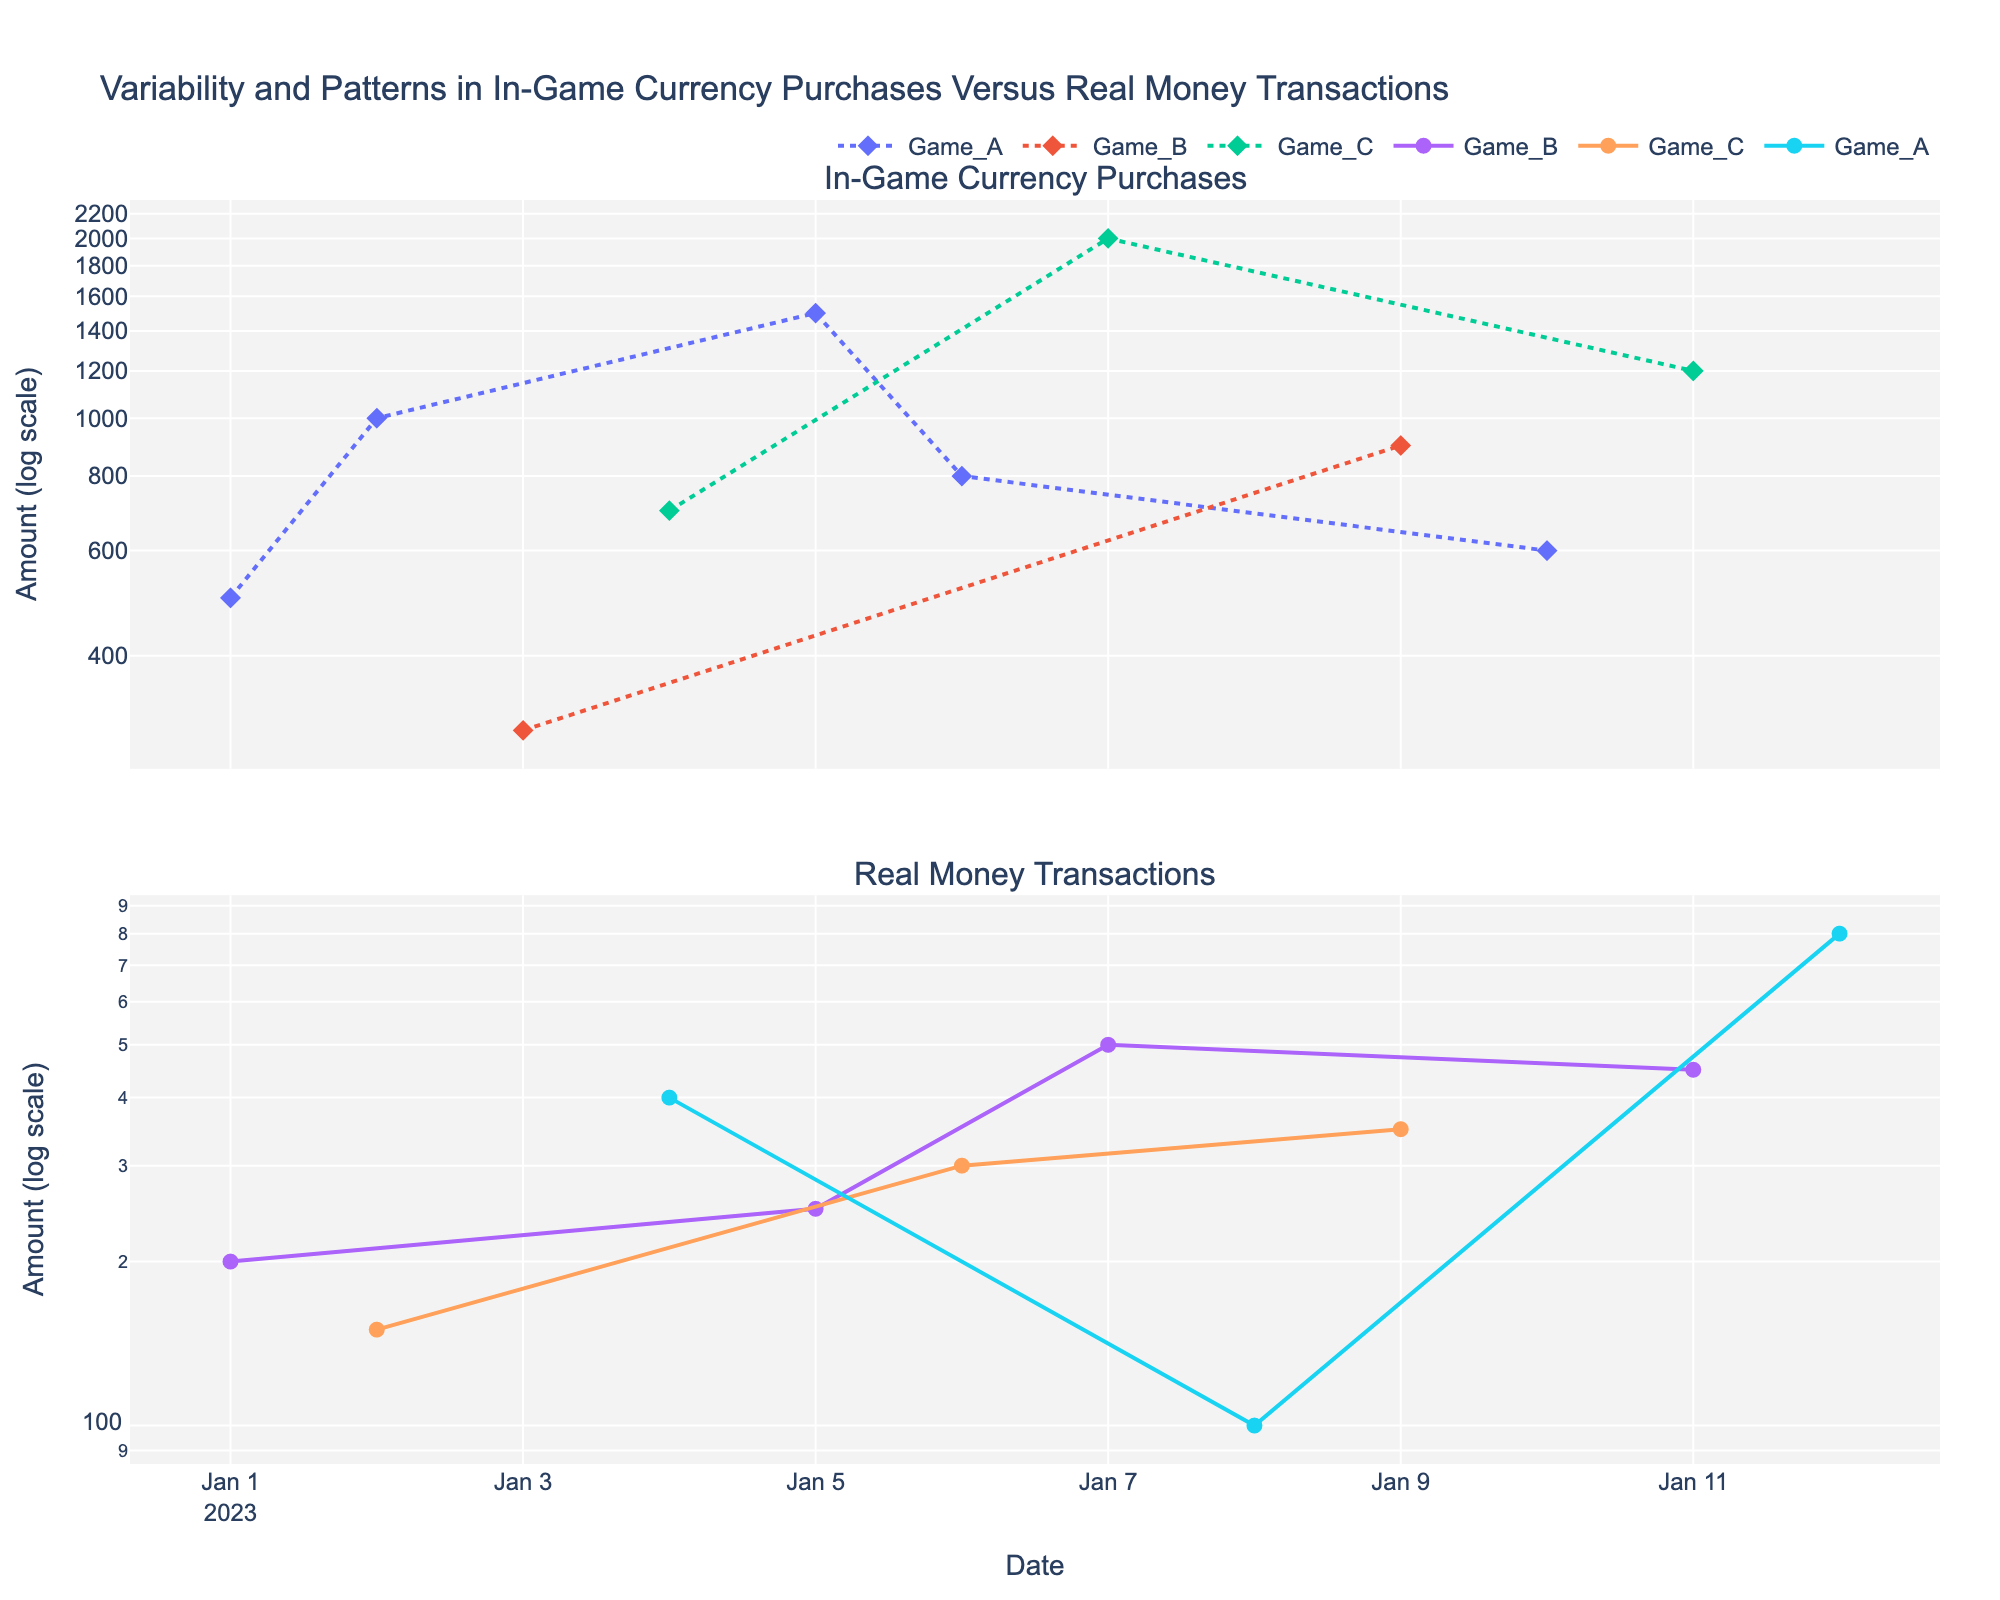What is the title of the figure? The title of the figure is usually located at the top of the plot and provides a summary of the data or the context of the figure. In this case, the title reads "Variability and Patterns in In-Game Currency Purchases Versus Real Money Transactions".
Answer: Variability and Patterns in In-Game Currency Purchases Versus Real Money Transactions How are the y-axes labeled? The y-axes labels are usually found next to the y-axes lines, providing information about the nature of the data displayed. Here, both y-axes are labeled as "Amount (log scale)" indicating that the amounts are represented on a logarithmic scale.
Answer: Amount (log scale) Which game has the highest amount of in-game currency purchase on a single date? To find the game with the highest amount of in-game currency purchase, we identify the highest point on the in-game currency purchase subplot and trace it back to the game it represents. The highest point corresponds to "Game_C" with an amount of 2000.
Answer: Game_C Among the games, which had the most variation in real money transactions? Variation in real money transactions can be determined by observing the spread or range of data points in the real money subplot. "Game_B" shows the most variation with data points ranging significantly from lower values around 200 to higher values up to 500.
Answer: Game_B On what date was the largest real money transaction made, and which game was it for? By identifying the highest peak on the real money transaction subplot and checking the corresponding date and game marker, we find the largest real money transaction of 800 happened on 2023-01-12 for "Game_A".
Answer: 2023-01-12, Game_A How does the variation in transaction amounts compare between in-game currency purchases and real money transactions? To compare variation, we look at the dispersion and spread of data points in both subplots. In-game currency purchases show larger variability with amounts ranging from 300 to 2000, while real money transactions range from 100 to 800. This indicates greater variation observed in in-game currency purchases.
Answer: In-game currency purchases show larger variation Which game had a consistent pattern for real money transactions over time? A consistent pattern can be identified by minimal fluctuations in the series of data points. "Game_C" in the real money subplot demonstrates a relatively consistent pattern with amounts around 300 to 350 unlike other games with significant ups and downs.
Answer: Game_C How many in-game currency purchases were made for Game_A? By counting the data points specifically for "Game_A" within the in-game currency subplot, we find there are four data points representing in-game currency purchases.
Answer: 4 